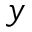Convert formula to latex. <formula><loc_0><loc_0><loc_500><loc_500>y</formula> 